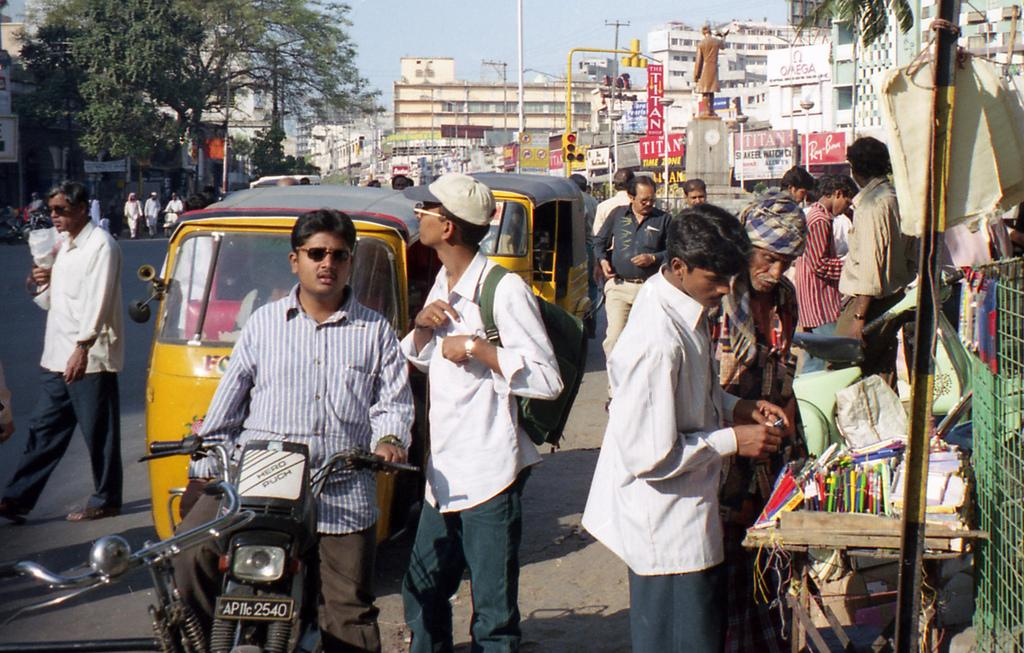How many people can be seen in the image? There are people in the image. What other objects or structures are present in the image? There are vehicles, a bike, poles, boards, a traffic signal, trees, a statue, a road, and buildings in the image. What can be seen in the background of the image? The sky is visible in the background of the image. How many boys are riding the squirrel in the image? There are no boys or squirrels present in the image. Is there a slope visible in the image? There is no slope visible in the image. 